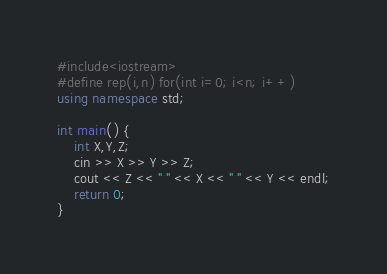Convert code to text. <code><loc_0><loc_0><loc_500><loc_500><_C++_>#include<iostream>
#define rep(i,n) for(int i=0; i<n; i++)
using namespace std;

int main() {
    int X,Y,Z;
    cin >> X >> Y >> Z;
    cout << Z << " " << X << " " << Y << endl;
    return 0;
}</code> 